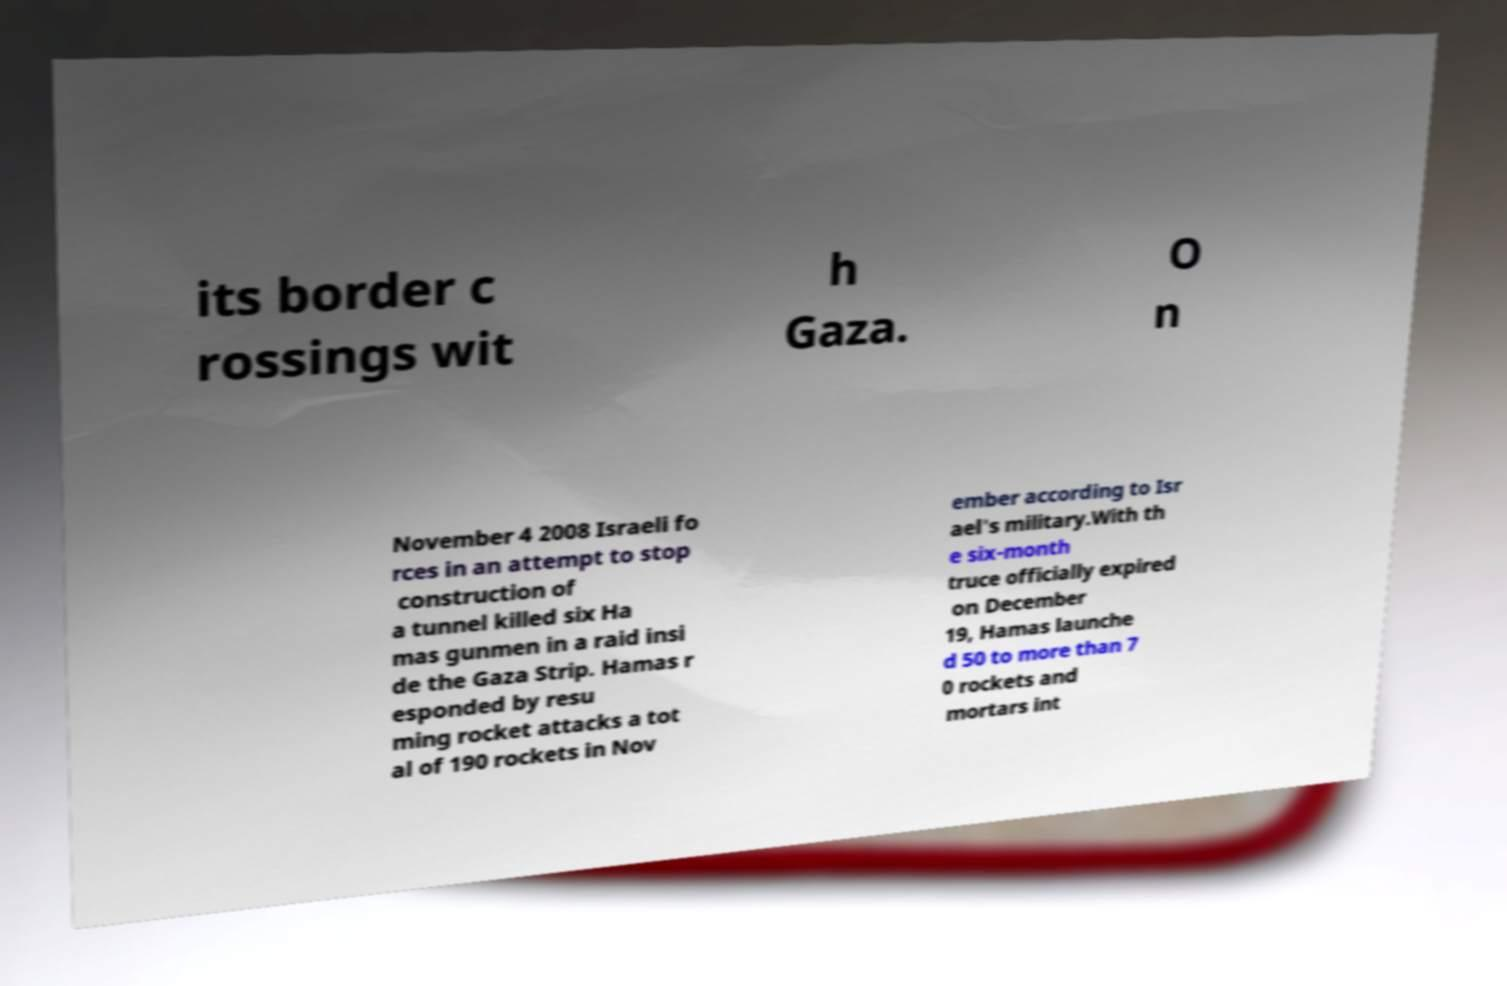Could you assist in decoding the text presented in this image and type it out clearly? its border c rossings wit h Gaza. O n November 4 2008 Israeli fo rces in an attempt to stop construction of a tunnel killed six Ha mas gunmen in a raid insi de the Gaza Strip. Hamas r esponded by resu ming rocket attacks a tot al of 190 rockets in Nov ember according to Isr ael's military.With th e six-month truce officially expired on December 19, Hamas launche d 50 to more than 7 0 rockets and mortars int 